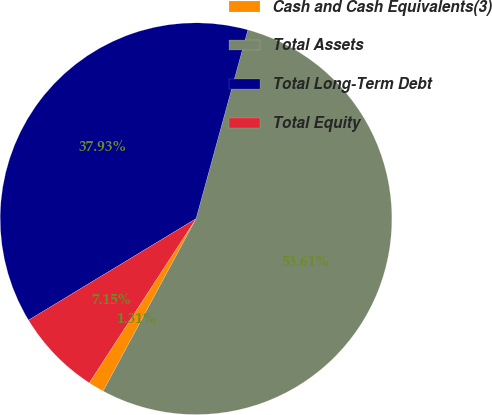Convert chart. <chart><loc_0><loc_0><loc_500><loc_500><pie_chart><fcel>Cash and Cash Equivalents(3)<fcel>Total Assets<fcel>Total Long-Term Debt<fcel>Total Equity<nl><fcel>1.31%<fcel>53.6%<fcel>37.93%<fcel>7.15%<nl></chart> 